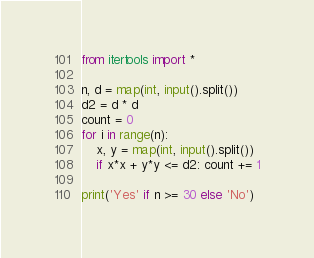Convert code to text. <code><loc_0><loc_0><loc_500><loc_500><_Python_>from itertools import *

n, d = map(int, input().split())
d2 = d * d
count = 0
for i in range(n):
    x, y = map(int, input().split())
    if x*x + y*y <= d2: count += 1

print('Yes' if n >= 30 else 'No')</code> 